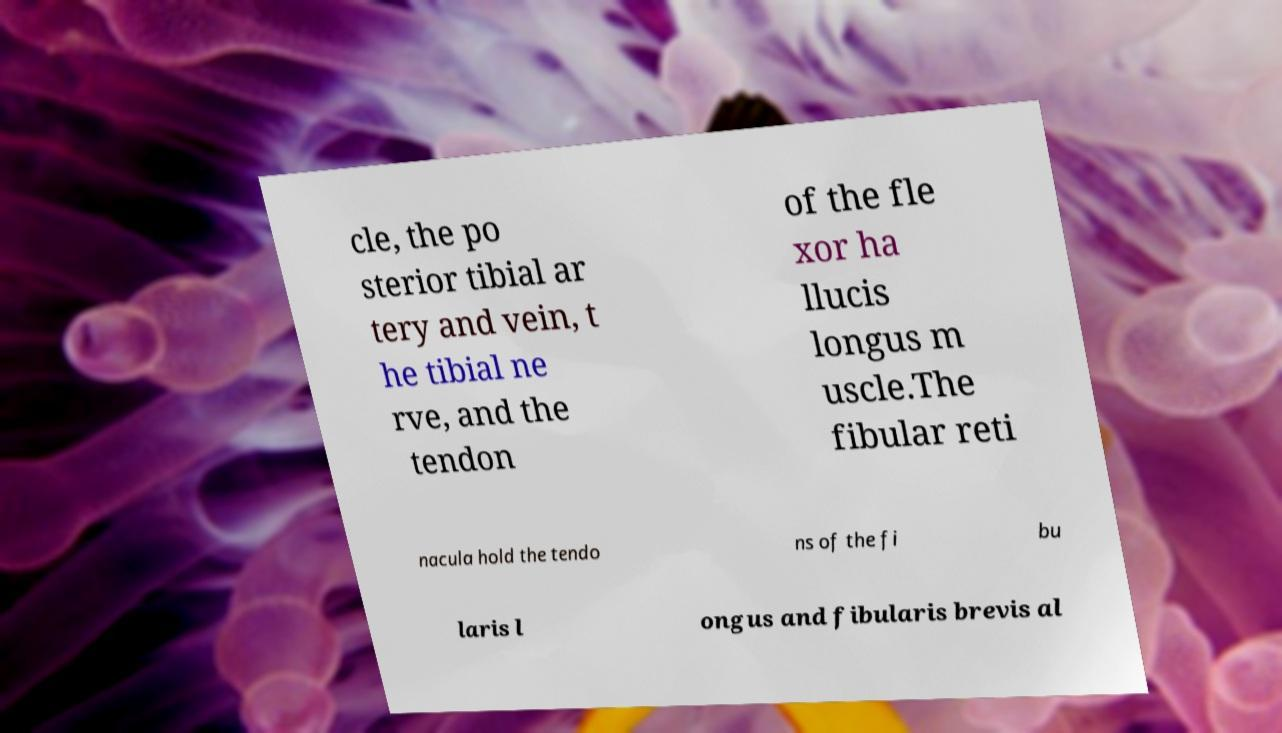Please read and relay the text visible in this image. What does it say? cle, the po sterior tibial ar tery and vein, t he tibial ne rve, and the tendon of the fle xor ha llucis longus m uscle.The fibular reti nacula hold the tendo ns of the fi bu laris l ongus and fibularis brevis al 